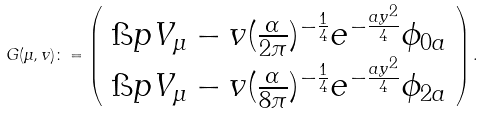Convert formula to latex. <formula><loc_0><loc_0><loc_500><loc_500>G ( \mu , v ) \colon = \left ( \begin{array} { c } \i p { V _ { \mu } - v } { ( \frac { \alpha } { 2 \pi } ) ^ { - \frac { 1 } { 4 } } e ^ { - \frac { a y ^ { 2 } } { 4 } } \phi _ { 0 a } } \\ \i p { V _ { \mu } - v } { ( \frac { \alpha } { 8 \pi } ) ^ { - \frac { 1 } { 4 } } e ^ { - \frac { a y ^ { 2 } } { 4 } } \phi _ { 2 a } } \end{array} \right ) .</formula> 